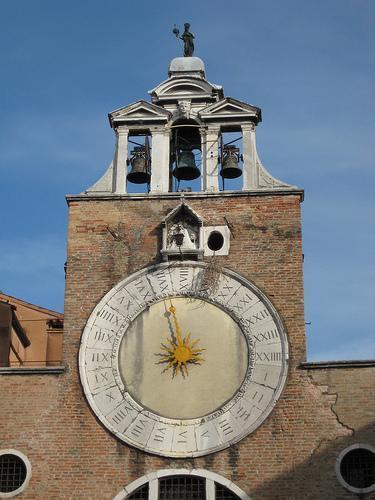How many windows are pictured?
Give a very brief answer. 5. How many bells are pictured?
Give a very brief answer. 3. 